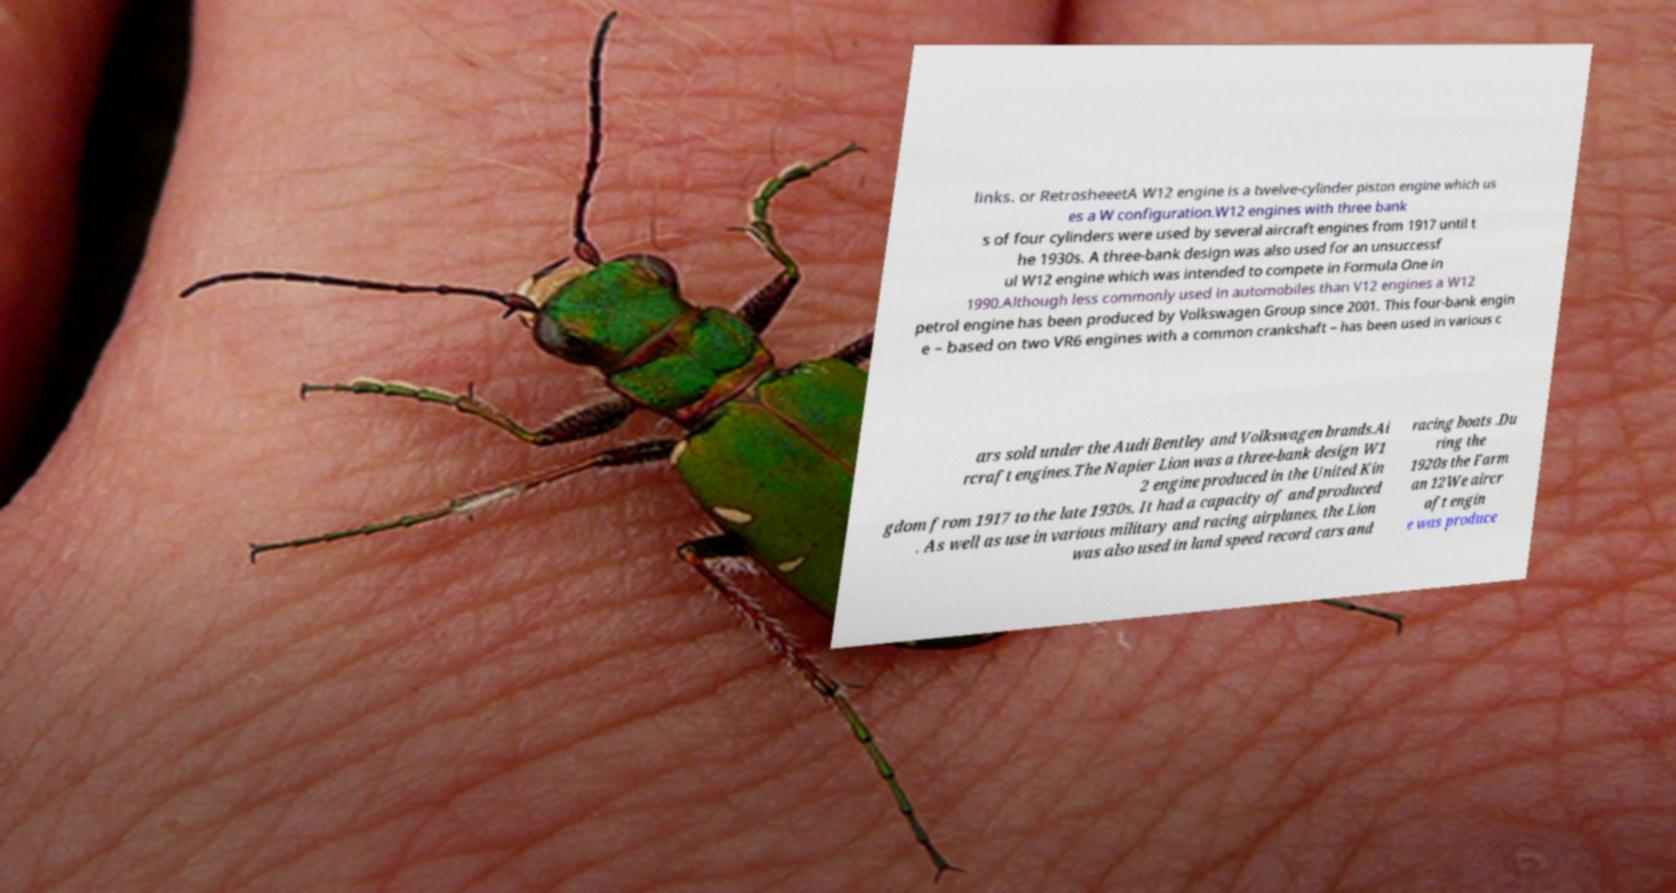Could you extract and type out the text from this image? links. or RetrosheeetA W12 engine is a twelve-cylinder piston engine which us es a W configuration.W12 engines with three bank s of four cylinders were used by several aircraft engines from 1917 until t he 1930s. A three-bank design was also used for an unsuccessf ul W12 engine which was intended to compete in Formula One in 1990.Although less commonly used in automobiles than V12 engines a W12 petrol engine has been produced by Volkswagen Group since 2001. This four-bank engin e – based on two VR6 engines with a common crankshaft – has been used in various c ars sold under the Audi Bentley and Volkswagen brands.Ai rcraft engines.The Napier Lion was a three-bank design W1 2 engine produced in the United Kin gdom from 1917 to the late 1930s. It had a capacity of and produced . As well as use in various military and racing airplanes, the Lion was also used in land speed record cars and racing boats .Du ring the 1920s the Farm an 12We aircr aft engin e was produce 